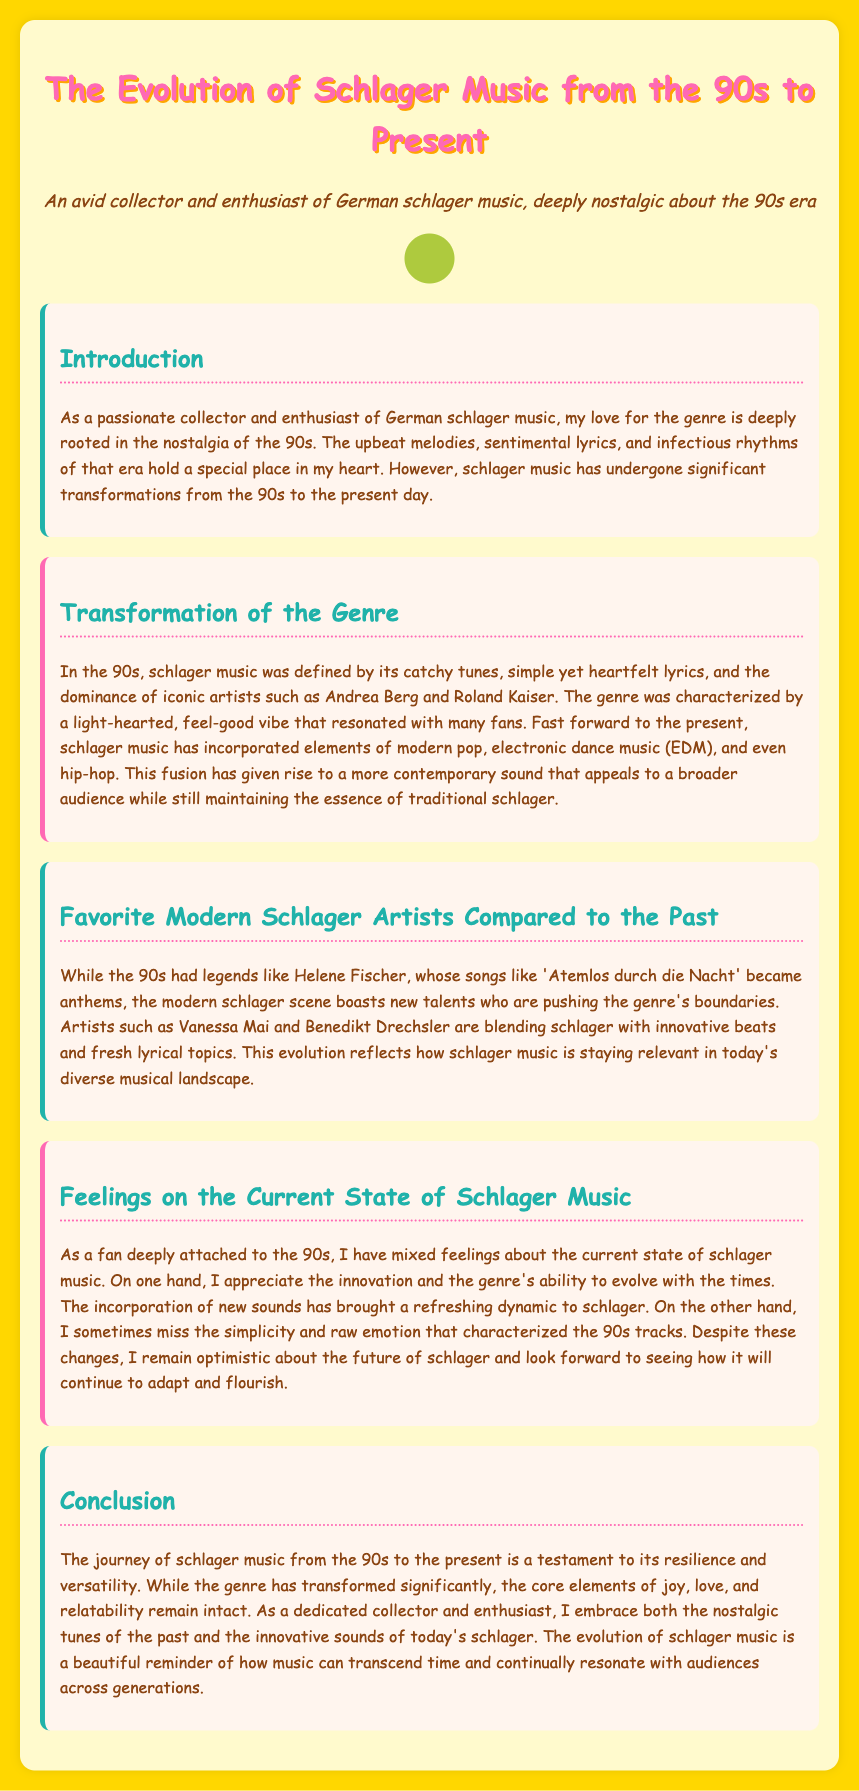What is the primary source of nostalgia for the author? The author expresses nostalgia for the 90s era of schlager music.
Answer: 90s era Which artists defined schlager music in the 90s? The document mentions Andrea Berg and Roland Kaiser as iconic artists from the 90s.
Answer: Andrea Berg and Roland Kaiser What modern elements have influenced schlager music today? The document states that modern schlager music has incorporated elements of pop, EDM, and hip-hop.
Answer: Pop, EDM, hip-hop Who is a popular modern schlager artist mentioned? Vanessa Mai is highlighted as a new talent in the modern schlager scene.
Answer: Vanessa Mai What is a primary emotion the author feels about current schlager music? The author has mixed feelings regarding the current state of schlager music.
Answer: Mixed feelings What is the overarching theme that remains intact in schlager music according to the author? The document emphasizes joy, love, and relatability as core elements of the genre.
Answer: Joy, love, relatability What was a significant song by Helene Fischer in the 90s? "Atemlos durch die Nacht" is mentioned as an anthem from that time.
Answer: Atemlos durch die Nacht How does the author view the future of schlager music? The author remains optimistic about the future of the genre despite changes.
Answer: Optimistic 